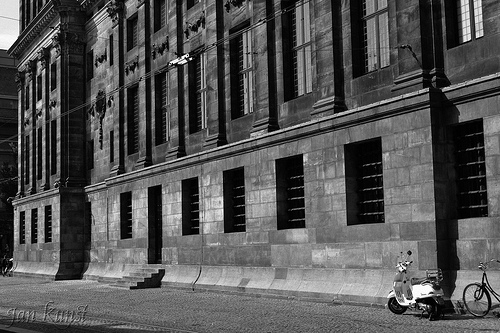How might the building appear during a sunny day with a bustling crowd around? On a sunny day, the building’s dark stone would contrast beautifully with the bright, clear sky. The sun would cast sharp shadows, emphasizing the textures of the bricks. The sidewalk would be filled with people walking by, some sitting on nearby benches, chatting or reading. There might be street vendors selling coffee or snacks, and the bicycle might have a basket with fresh flowers or groceries attached to it. The lively energy of the crowd would breathe life into the historic structure, making it a vibrant part of the community. 